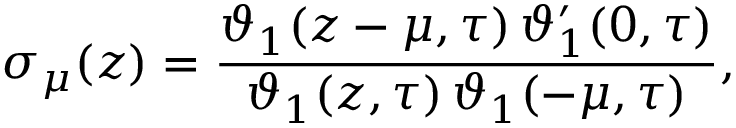<formula> <loc_0><loc_0><loc_500><loc_500>\sigma _ { \mu } ( z ) = \frac { \vartheta _ { 1 } ( z - \mu , \tau ) \, \vartheta _ { 1 } ^ { \prime } ( 0 , \tau ) } { \vartheta _ { 1 } ( z , \tau ) \, \vartheta _ { 1 } ( - \mu , \tau ) } ,</formula> 